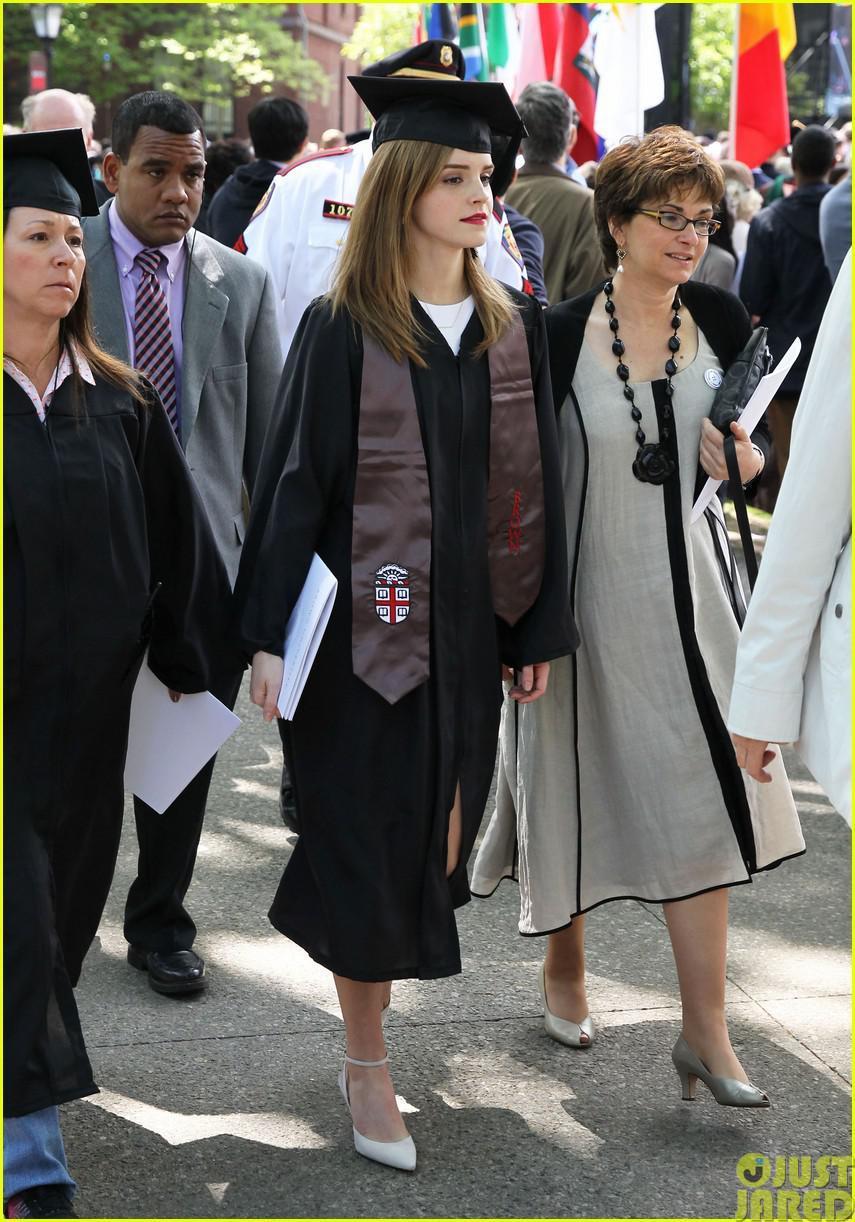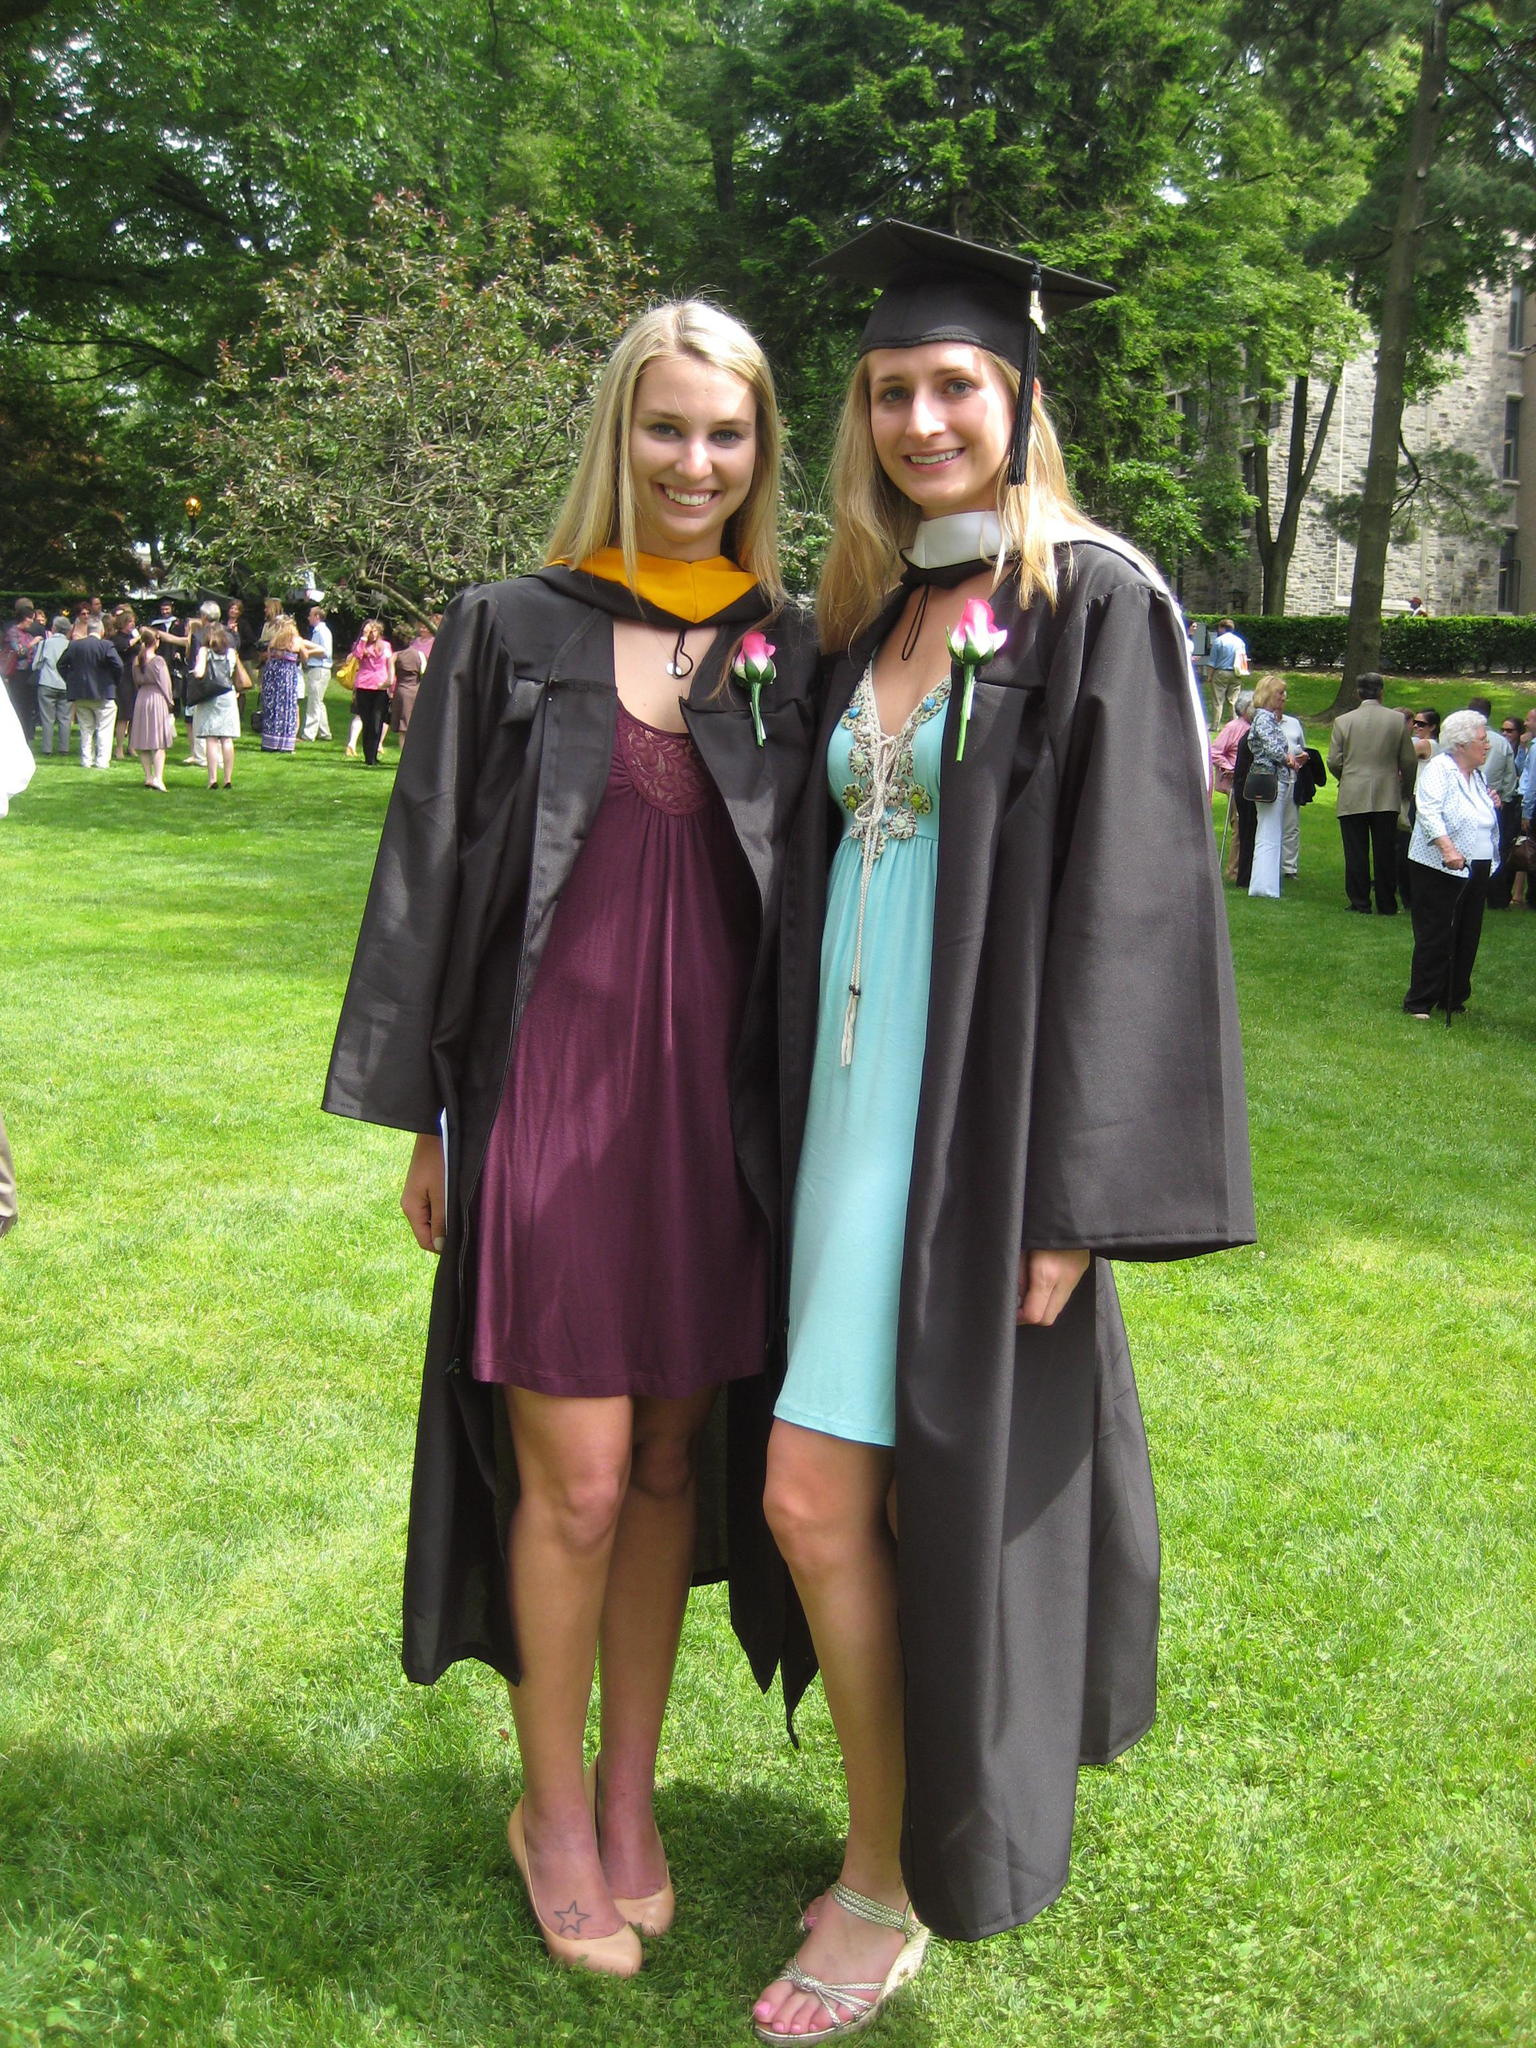The first image is the image on the left, the second image is the image on the right. Examine the images to the left and right. Is the description "One image shows one male graduate posing with one female in the foreground." accurate? Answer yes or no. No. 